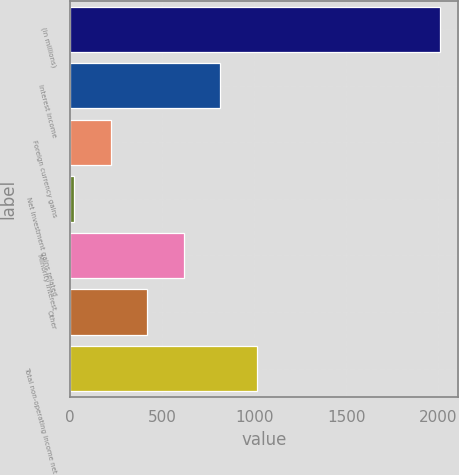<chart> <loc_0><loc_0><loc_500><loc_500><bar_chart><fcel>(in millions)<fcel>Interest income<fcel>Foreign currency gains<fcel>Net investment gains related<fcel>Minority interest<fcel>Other<fcel>Total non-operating income net<nl><fcel>2007<fcel>816<fcel>220.5<fcel>22<fcel>617.5<fcel>419<fcel>1014.5<nl></chart> 